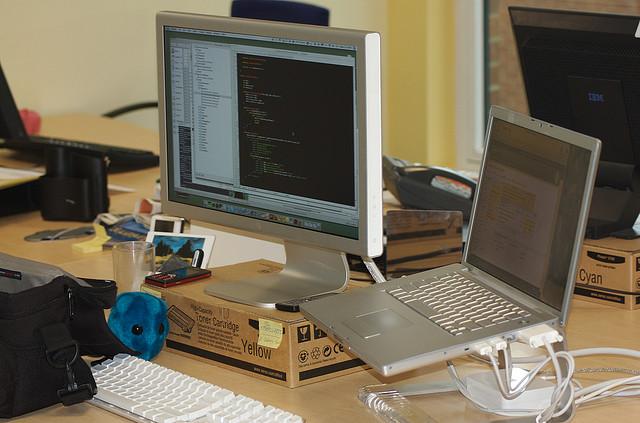What brand is the computer?
Concise answer only. Apple. What is the black item near the keyboard?
Be succinct. Bag. How many computers do you see?
Quick response, please. 2. 